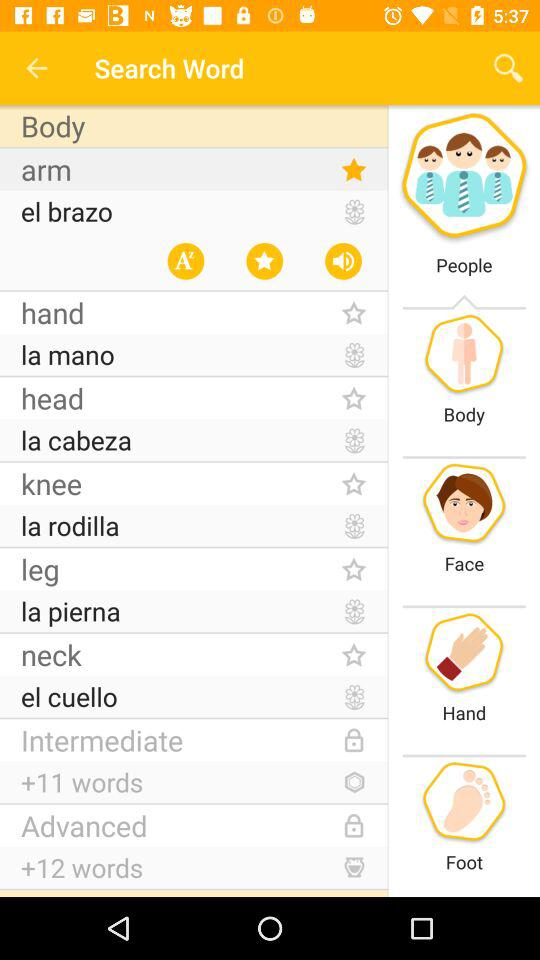Which is the starred word? The starred word is "arm". 